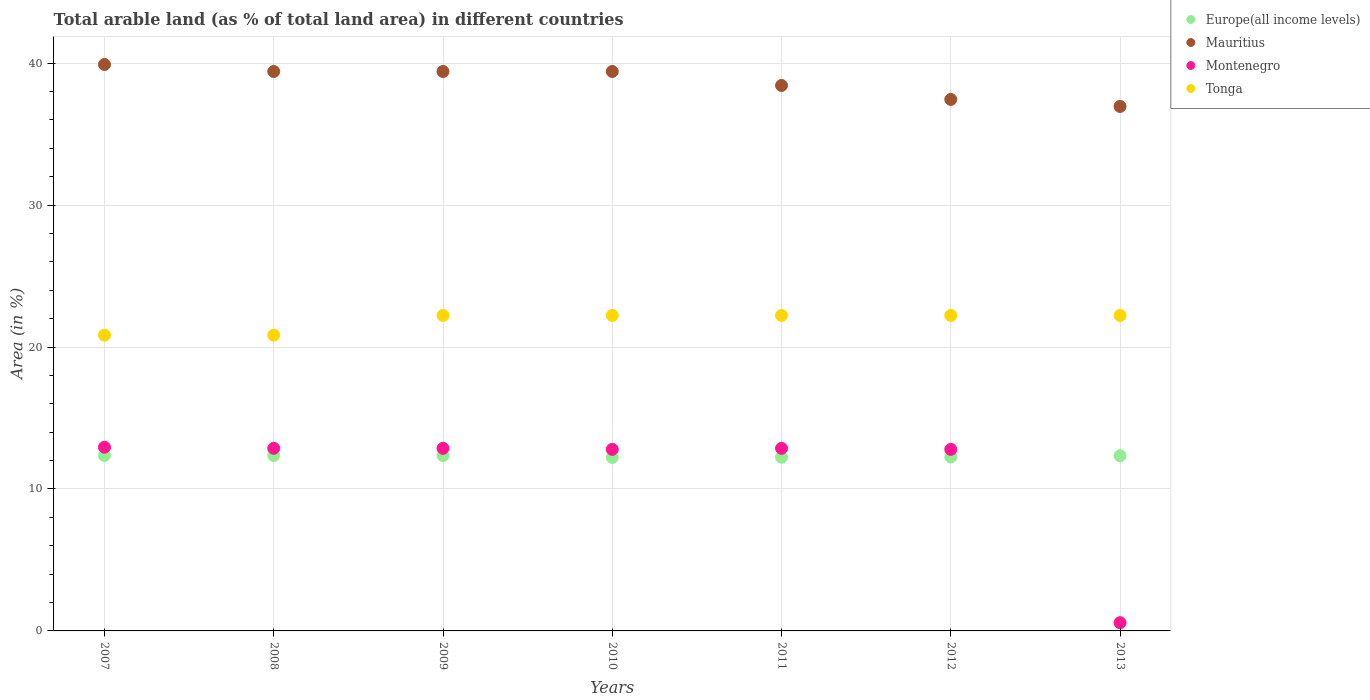How many different coloured dotlines are there?
Keep it short and to the point. 4. What is the percentage of arable land in Europe(all income levels) in 2013?
Your answer should be compact. 12.34. Across all years, what is the maximum percentage of arable land in Tonga?
Provide a succinct answer. 22.22. Across all years, what is the minimum percentage of arable land in Montenegro?
Provide a short and direct response. 0.58. In which year was the percentage of arable land in Montenegro maximum?
Your response must be concise. 2007. What is the total percentage of arable land in Mauritius in the graph?
Your answer should be compact. 270.94. What is the difference between the percentage of arable land in Tonga in 2007 and that in 2013?
Provide a short and direct response. -1.39. What is the difference between the percentage of arable land in Mauritius in 2007 and the percentage of arable land in Montenegro in 2012?
Give a very brief answer. 27.11. What is the average percentage of arable land in Europe(all income levels) per year?
Offer a very short reply. 12.3. In the year 2009, what is the difference between the percentage of arable land in Tonga and percentage of arable land in Europe(all income levels)?
Make the answer very short. 9.87. What is the ratio of the percentage of arable land in Tonga in 2008 to that in 2011?
Ensure brevity in your answer.  0.94. Is the percentage of arable land in Tonga in 2007 less than that in 2010?
Give a very brief answer. Yes. What is the difference between the highest and the second highest percentage of arable land in Montenegro?
Offer a terse response. 0.07. What is the difference between the highest and the lowest percentage of arable land in Mauritius?
Your response must be concise. 2.96. In how many years, is the percentage of arable land in Tonga greater than the average percentage of arable land in Tonga taken over all years?
Give a very brief answer. 5. Is the sum of the percentage of arable land in Montenegro in 2007 and 2008 greater than the maximum percentage of arable land in Europe(all income levels) across all years?
Provide a succinct answer. Yes. Is it the case that in every year, the sum of the percentage of arable land in Mauritius and percentage of arable land in Europe(all income levels)  is greater than the sum of percentage of arable land in Montenegro and percentage of arable land in Tonga?
Your response must be concise. Yes. Is it the case that in every year, the sum of the percentage of arable land in Montenegro and percentage of arable land in Europe(all income levels)  is greater than the percentage of arable land in Mauritius?
Your response must be concise. No. Is the percentage of arable land in Mauritius strictly greater than the percentage of arable land in Montenegro over the years?
Provide a short and direct response. Yes. Is the percentage of arable land in Europe(all income levels) strictly less than the percentage of arable land in Montenegro over the years?
Give a very brief answer. No. What is the difference between two consecutive major ticks on the Y-axis?
Your answer should be very brief. 10. Where does the legend appear in the graph?
Provide a short and direct response. Top right. How many legend labels are there?
Give a very brief answer. 4. How are the legend labels stacked?
Make the answer very short. Vertical. What is the title of the graph?
Make the answer very short. Total arable land (as % of total land area) in different countries. What is the label or title of the X-axis?
Keep it short and to the point. Years. What is the label or title of the Y-axis?
Keep it short and to the point. Area (in %). What is the Area (in %) in Europe(all income levels) in 2007?
Your response must be concise. 12.36. What is the Area (in %) of Mauritius in 2007?
Your answer should be compact. 39.9. What is the Area (in %) of Montenegro in 2007?
Your answer should be very brief. 12.94. What is the Area (in %) of Tonga in 2007?
Your response must be concise. 20.83. What is the Area (in %) of Europe(all income levels) in 2008?
Provide a succinct answer. 12.36. What is the Area (in %) of Mauritius in 2008?
Your answer should be very brief. 39.41. What is the Area (in %) in Montenegro in 2008?
Provide a short and direct response. 12.86. What is the Area (in %) of Tonga in 2008?
Your answer should be very brief. 20.83. What is the Area (in %) in Europe(all income levels) in 2009?
Provide a short and direct response. 12.35. What is the Area (in %) of Mauritius in 2009?
Provide a succinct answer. 39.41. What is the Area (in %) in Montenegro in 2009?
Offer a terse response. 12.86. What is the Area (in %) in Tonga in 2009?
Provide a short and direct response. 22.22. What is the Area (in %) of Europe(all income levels) in 2010?
Provide a succinct answer. 12.22. What is the Area (in %) in Mauritius in 2010?
Ensure brevity in your answer.  39.41. What is the Area (in %) in Montenegro in 2010?
Your response must be concise. 12.79. What is the Area (in %) of Tonga in 2010?
Make the answer very short. 22.22. What is the Area (in %) of Europe(all income levels) in 2011?
Offer a very short reply. 12.24. What is the Area (in %) of Mauritius in 2011?
Ensure brevity in your answer.  38.42. What is the Area (in %) of Montenegro in 2011?
Your response must be concise. 12.86. What is the Area (in %) in Tonga in 2011?
Keep it short and to the point. 22.22. What is the Area (in %) in Europe(all income levels) in 2012?
Your response must be concise. 12.26. What is the Area (in %) in Mauritius in 2012?
Offer a very short reply. 37.44. What is the Area (in %) in Montenegro in 2012?
Make the answer very short. 12.79. What is the Area (in %) in Tonga in 2012?
Provide a short and direct response. 22.22. What is the Area (in %) in Europe(all income levels) in 2013?
Keep it short and to the point. 12.34. What is the Area (in %) in Mauritius in 2013?
Provide a succinct answer. 36.95. What is the Area (in %) in Montenegro in 2013?
Ensure brevity in your answer.  0.58. What is the Area (in %) of Tonga in 2013?
Offer a very short reply. 22.22. Across all years, what is the maximum Area (in %) of Europe(all income levels)?
Offer a terse response. 12.36. Across all years, what is the maximum Area (in %) of Mauritius?
Your response must be concise. 39.9. Across all years, what is the maximum Area (in %) in Montenegro?
Offer a terse response. 12.94. Across all years, what is the maximum Area (in %) of Tonga?
Your answer should be compact. 22.22. Across all years, what is the minimum Area (in %) in Europe(all income levels)?
Make the answer very short. 12.22. Across all years, what is the minimum Area (in %) in Mauritius?
Offer a very short reply. 36.95. Across all years, what is the minimum Area (in %) of Montenegro?
Your response must be concise. 0.58. Across all years, what is the minimum Area (in %) of Tonga?
Ensure brevity in your answer.  20.83. What is the total Area (in %) in Europe(all income levels) in the graph?
Give a very brief answer. 86.12. What is the total Area (in %) of Mauritius in the graph?
Make the answer very short. 270.94. What is the total Area (in %) in Montenegro in the graph?
Make the answer very short. 77.68. What is the total Area (in %) in Tonga in the graph?
Offer a very short reply. 152.78. What is the difference between the Area (in %) in Europe(all income levels) in 2007 and that in 2008?
Provide a short and direct response. 0. What is the difference between the Area (in %) of Mauritius in 2007 and that in 2008?
Your answer should be compact. 0.49. What is the difference between the Area (in %) of Montenegro in 2007 and that in 2008?
Keep it short and to the point. 0.07. What is the difference between the Area (in %) in Europe(all income levels) in 2007 and that in 2009?
Provide a short and direct response. 0.01. What is the difference between the Area (in %) in Mauritius in 2007 and that in 2009?
Ensure brevity in your answer.  0.49. What is the difference between the Area (in %) of Montenegro in 2007 and that in 2009?
Ensure brevity in your answer.  0.07. What is the difference between the Area (in %) of Tonga in 2007 and that in 2009?
Keep it short and to the point. -1.39. What is the difference between the Area (in %) of Europe(all income levels) in 2007 and that in 2010?
Offer a terse response. 0.14. What is the difference between the Area (in %) in Mauritius in 2007 and that in 2010?
Offer a very short reply. 0.49. What is the difference between the Area (in %) in Montenegro in 2007 and that in 2010?
Your answer should be compact. 0.15. What is the difference between the Area (in %) in Tonga in 2007 and that in 2010?
Your answer should be very brief. -1.39. What is the difference between the Area (in %) of Europe(all income levels) in 2007 and that in 2011?
Provide a short and direct response. 0.12. What is the difference between the Area (in %) in Mauritius in 2007 and that in 2011?
Offer a very short reply. 1.48. What is the difference between the Area (in %) in Montenegro in 2007 and that in 2011?
Offer a very short reply. 0.07. What is the difference between the Area (in %) in Tonga in 2007 and that in 2011?
Your answer should be compact. -1.39. What is the difference between the Area (in %) in Europe(all income levels) in 2007 and that in 2012?
Make the answer very short. 0.1. What is the difference between the Area (in %) in Mauritius in 2007 and that in 2012?
Offer a very short reply. 2.46. What is the difference between the Area (in %) in Montenegro in 2007 and that in 2012?
Your response must be concise. 0.15. What is the difference between the Area (in %) in Tonga in 2007 and that in 2012?
Give a very brief answer. -1.39. What is the difference between the Area (in %) in Europe(all income levels) in 2007 and that in 2013?
Your response must be concise. 0.02. What is the difference between the Area (in %) of Mauritius in 2007 and that in 2013?
Give a very brief answer. 2.96. What is the difference between the Area (in %) of Montenegro in 2007 and that in 2013?
Your answer should be compact. 12.36. What is the difference between the Area (in %) in Tonga in 2007 and that in 2013?
Your answer should be very brief. -1.39. What is the difference between the Area (in %) in Europe(all income levels) in 2008 and that in 2009?
Offer a terse response. 0.01. What is the difference between the Area (in %) of Montenegro in 2008 and that in 2009?
Your response must be concise. 0. What is the difference between the Area (in %) in Tonga in 2008 and that in 2009?
Your answer should be compact. -1.39. What is the difference between the Area (in %) of Europe(all income levels) in 2008 and that in 2010?
Make the answer very short. 0.14. What is the difference between the Area (in %) in Montenegro in 2008 and that in 2010?
Your answer should be very brief. 0.07. What is the difference between the Area (in %) in Tonga in 2008 and that in 2010?
Your answer should be very brief. -1.39. What is the difference between the Area (in %) of Europe(all income levels) in 2008 and that in 2011?
Give a very brief answer. 0.12. What is the difference between the Area (in %) in Mauritius in 2008 and that in 2011?
Your answer should be very brief. 0.99. What is the difference between the Area (in %) in Tonga in 2008 and that in 2011?
Your response must be concise. -1.39. What is the difference between the Area (in %) in Europe(all income levels) in 2008 and that in 2012?
Your answer should be very brief. 0.1. What is the difference between the Area (in %) in Mauritius in 2008 and that in 2012?
Your response must be concise. 1.97. What is the difference between the Area (in %) in Montenegro in 2008 and that in 2012?
Provide a short and direct response. 0.07. What is the difference between the Area (in %) in Tonga in 2008 and that in 2012?
Give a very brief answer. -1.39. What is the difference between the Area (in %) in Europe(all income levels) in 2008 and that in 2013?
Ensure brevity in your answer.  0.02. What is the difference between the Area (in %) in Mauritius in 2008 and that in 2013?
Give a very brief answer. 2.46. What is the difference between the Area (in %) in Montenegro in 2008 and that in 2013?
Offer a very short reply. 12.28. What is the difference between the Area (in %) in Tonga in 2008 and that in 2013?
Provide a short and direct response. -1.39. What is the difference between the Area (in %) in Europe(all income levels) in 2009 and that in 2010?
Your answer should be compact. 0.13. What is the difference between the Area (in %) in Montenegro in 2009 and that in 2010?
Your answer should be very brief. 0.07. What is the difference between the Area (in %) in Europe(all income levels) in 2009 and that in 2011?
Make the answer very short. 0.12. What is the difference between the Area (in %) in Mauritius in 2009 and that in 2011?
Make the answer very short. 0.99. What is the difference between the Area (in %) in Europe(all income levels) in 2009 and that in 2012?
Your response must be concise. 0.1. What is the difference between the Area (in %) in Mauritius in 2009 and that in 2012?
Provide a succinct answer. 1.97. What is the difference between the Area (in %) of Montenegro in 2009 and that in 2012?
Give a very brief answer. 0.07. What is the difference between the Area (in %) of Europe(all income levels) in 2009 and that in 2013?
Make the answer very short. 0.01. What is the difference between the Area (in %) of Mauritius in 2009 and that in 2013?
Ensure brevity in your answer.  2.46. What is the difference between the Area (in %) in Montenegro in 2009 and that in 2013?
Provide a succinct answer. 12.28. What is the difference between the Area (in %) in Europe(all income levels) in 2010 and that in 2011?
Your answer should be compact. -0.02. What is the difference between the Area (in %) of Mauritius in 2010 and that in 2011?
Provide a succinct answer. 0.99. What is the difference between the Area (in %) of Montenegro in 2010 and that in 2011?
Ensure brevity in your answer.  -0.07. What is the difference between the Area (in %) of Tonga in 2010 and that in 2011?
Make the answer very short. 0. What is the difference between the Area (in %) of Europe(all income levels) in 2010 and that in 2012?
Your answer should be very brief. -0.04. What is the difference between the Area (in %) in Mauritius in 2010 and that in 2012?
Offer a very short reply. 1.97. What is the difference between the Area (in %) of Montenegro in 2010 and that in 2012?
Your answer should be very brief. 0. What is the difference between the Area (in %) of Tonga in 2010 and that in 2012?
Provide a short and direct response. 0. What is the difference between the Area (in %) of Europe(all income levels) in 2010 and that in 2013?
Make the answer very short. -0.12. What is the difference between the Area (in %) of Mauritius in 2010 and that in 2013?
Keep it short and to the point. 2.46. What is the difference between the Area (in %) of Montenegro in 2010 and that in 2013?
Provide a succinct answer. 12.21. What is the difference between the Area (in %) in Tonga in 2010 and that in 2013?
Provide a succinct answer. 0. What is the difference between the Area (in %) of Europe(all income levels) in 2011 and that in 2012?
Offer a very short reply. -0.02. What is the difference between the Area (in %) of Mauritius in 2011 and that in 2012?
Your answer should be very brief. 0.99. What is the difference between the Area (in %) of Montenegro in 2011 and that in 2012?
Your response must be concise. 0.07. What is the difference between the Area (in %) of Tonga in 2011 and that in 2012?
Give a very brief answer. 0. What is the difference between the Area (in %) of Europe(all income levels) in 2011 and that in 2013?
Your response must be concise. -0.1. What is the difference between the Area (in %) in Mauritius in 2011 and that in 2013?
Your answer should be very brief. 1.48. What is the difference between the Area (in %) of Montenegro in 2011 and that in 2013?
Your answer should be very brief. 12.28. What is the difference between the Area (in %) of Europe(all income levels) in 2012 and that in 2013?
Make the answer very short. -0.08. What is the difference between the Area (in %) in Mauritius in 2012 and that in 2013?
Keep it short and to the point. 0.49. What is the difference between the Area (in %) in Montenegro in 2012 and that in 2013?
Offer a very short reply. 12.21. What is the difference between the Area (in %) in Tonga in 2012 and that in 2013?
Provide a short and direct response. 0. What is the difference between the Area (in %) of Europe(all income levels) in 2007 and the Area (in %) of Mauritius in 2008?
Your response must be concise. -27.05. What is the difference between the Area (in %) in Europe(all income levels) in 2007 and the Area (in %) in Montenegro in 2008?
Your answer should be very brief. -0.5. What is the difference between the Area (in %) of Europe(all income levels) in 2007 and the Area (in %) of Tonga in 2008?
Provide a succinct answer. -8.47. What is the difference between the Area (in %) of Mauritius in 2007 and the Area (in %) of Montenegro in 2008?
Keep it short and to the point. 27.04. What is the difference between the Area (in %) in Mauritius in 2007 and the Area (in %) in Tonga in 2008?
Keep it short and to the point. 19.07. What is the difference between the Area (in %) in Montenegro in 2007 and the Area (in %) in Tonga in 2008?
Your answer should be compact. -7.9. What is the difference between the Area (in %) of Europe(all income levels) in 2007 and the Area (in %) of Mauritius in 2009?
Provide a short and direct response. -27.05. What is the difference between the Area (in %) in Europe(all income levels) in 2007 and the Area (in %) in Montenegro in 2009?
Provide a succinct answer. -0.5. What is the difference between the Area (in %) in Europe(all income levels) in 2007 and the Area (in %) in Tonga in 2009?
Give a very brief answer. -9.86. What is the difference between the Area (in %) in Mauritius in 2007 and the Area (in %) in Montenegro in 2009?
Provide a succinct answer. 27.04. What is the difference between the Area (in %) in Mauritius in 2007 and the Area (in %) in Tonga in 2009?
Keep it short and to the point. 17.68. What is the difference between the Area (in %) of Montenegro in 2007 and the Area (in %) of Tonga in 2009?
Your answer should be compact. -9.29. What is the difference between the Area (in %) of Europe(all income levels) in 2007 and the Area (in %) of Mauritius in 2010?
Provide a succinct answer. -27.05. What is the difference between the Area (in %) in Europe(all income levels) in 2007 and the Area (in %) in Montenegro in 2010?
Your response must be concise. -0.43. What is the difference between the Area (in %) in Europe(all income levels) in 2007 and the Area (in %) in Tonga in 2010?
Offer a terse response. -9.86. What is the difference between the Area (in %) of Mauritius in 2007 and the Area (in %) of Montenegro in 2010?
Your response must be concise. 27.11. What is the difference between the Area (in %) in Mauritius in 2007 and the Area (in %) in Tonga in 2010?
Provide a succinct answer. 17.68. What is the difference between the Area (in %) of Montenegro in 2007 and the Area (in %) of Tonga in 2010?
Give a very brief answer. -9.29. What is the difference between the Area (in %) of Europe(all income levels) in 2007 and the Area (in %) of Mauritius in 2011?
Offer a very short reply. -26.07. What is the difference between the Area (in %) in Europe(all income levels) in 2007 and the Area (in %) in Montenegro in 2011?
Offer a very short reply. -0.5. What is the difference between the Area (in %) of Europe(all income levels) in 2007 and the Area (in %) of Tonga in 2011?
Provide a short and direct response. -9.86. What is the difference between the Area (in %) of Mauritius in 2007 and the Area (in %) of Montenegro in 2011?
Provide a succinct answer. 27.04. What is the difference between the Area (in %) in Mauritius in 2007 and the Area (in %) in Tonga in 2011?
Offer a very short reply. 17.68. What is the difference between the Area (in %) of Montenegro in 2007 and the Area (in %) of Tonga in 2011?
Keep it short and to the point. -9.29. What is the difference between the Area (in %) in Europe(all income levels) in 2007 and the Area (in %) in Mauritius in 2012?
Your answer should be compact. -25.08. What is the difference between the Area (in %) in Europe(all income levels) in 2007 and the Area (in %) in Montenegro in 2012?
Your answer should be compact. -0.43. What is the difference between the Area (in %) of Europe(all income levels) in 2007 and the Area (in %) of Tonga in 2012?
Give a very brief answer. -9.86. What is the difference between the Area (in %) in Mauritius in 2007 and the Area (in %) in Montenegro in 2012?
Keep it short and to the point. 27.11. What is the difference between the Area (in %) of Mauritius in 2007 and the Area (in %) of Tonga in 2012?
Offer a terse response. 17.68. What is the difference between the Area (in %) in Montenegro in 2007 and the Area (in %) in Tonga in 2012?
Offer a very short reply. -9.29. What is the difference between the Area (in %) in Europe(all income levels) in 2007 and the Area (in %) in Mauritius in 2013?
Ensure brevity in your answer.  -24.59. What is the difference between the Area (in %) in Europe(all income levels) in 2007 and the Area (in %) in Montenegro in 2013?
Provide a succinct answer. 11.78. What is the difference between the Area (in %) of Europe(all income levels) in 2007 and the Area (in %) of Tonga in 2013?
Provide a succinct answer. -9.86. What is the difference between the Area (in %) in Mauritius in 2007 and the Area (in %) in Montenegro in 2013?
Provide a succinct answer. 39.32. What is the difference between the Area (in %) in Mauritius in 2007 and the Area (in %) in Tonga in 2013?
Make the answer very short. 17.68. What is the difference between the Area (in %) of Montenegro in 2007 and the Area (in %) of Tonga in 2013?
Offer a very short reply. -9.29. What is the difference between the Area (in %) in Europe(all income levels) in 2008 and the Area (in %) in Mauritius in 2009?
Your answer should be very brief. -27.05. What is the difference between the Area (in %) in Europe(all income levels) in 2008 and the Area (in %) in Montenegro in 2009?
Your response must be concise. -0.5. What is the difference between the Area (in %) in Europe(all income levels) in 2008 and the Area (in %) in Tonga in 2009?
Provide a short and direct response. -9.86. What is the difference between the Area (in %) of Mauritius in 2008 and the Area (in %) of Montenegro in 2009?
Give a very brief answer. 26.55. What is the difference between the Area (in %) of Mauritius in 2008 and the Area (in %) of Tonga in 2009?
Your response must be concise. 17.19. What is the difference between the Area (in %) of Montenegro in 2008 and the Area (in %) of Tonga in 2009?
Provide a succinct answer. -9.36. What is the difference between the Area (in %) in Europe(all income levels) in 2008 and the Area (in %) in Mauritius in 2010?
Your answer should be compact. -27.05. What is the difference between the Area (in %) in Europe(all income levels) in 2008 and the Area (in %) in Montenegro in 2010?
Your response must be concise. -0.43. What is the difference between the Area (in %) in Europe(all income levels) in 2008 and the Area (in %) in Tonga in 2010?
Give a very brief answer. -9.86. What is the difference between the Area (in %) of Mauritius in 2008 and the Area (in %) of Montenegro in 2010?
Provide a succinct answer. 26.62. What is the difference between the Area (in %) of Mauritius in 2008 and the Area (in %) of Tonga in 2010?
Offer a very short reply. 17.19. What is the difference between the Area (in %) in Montenegro in 2008 and the Area (in %) in Tonga in 2010?
Offer a terse response. -9.36. What is the difference between the Area (in %) of Europe(all income levels) in 2008 and the Area (in %) of Mauritius in 2011?
Make the answer very short. -26.07. What is the difference between the Area (in %) of Europe(all income levels) in 2008 and the Area (in %) of Montenegro in 2011?
Provide a succinct answer. -0.5. What is the difference between the Area (in %) of Europe(all income levels) in 2008 and the Area (in %) of Tonga in 2011?
Keep it short and to the point. -9.86. What is the difference between the Area (in %) of Mauritius in 2008 and the Area (in %) of Montenegro in 2011?
Offer a very short reply. 26.55. What is the difference between the Area (in %) of Mauritius in 2008 and the Area (in %) of Tonga in 2011?
Your answer should be very brief. 17.19. What is the difference between the Area (in %) in Montenegro in 2008 and the Area (in %) in Tonga in 2011?
Offer a very short reply. -9.36. What is the difference between the Area (in %) in Europe(all income levels) in 2008 and the Area (in %) in Mauritius in 2012?
Give a very brief answer. -25.08. What is the difference between the Area (in %) of Europe(all income levels) in 2008 and the Area (in %) of Montenegro in 2012?
Provide a succinct answer. -0.43. What is the difference between the Area (in %) in Europe(all income levels) in 2008 and the Area (in %) in Tonga in 2012?
Your response must be concise. -9.86. What is the difference between the Area (in %) of Mauritius in 2008 and the Area (in %) of Montenegro in 2012?
Offer a very short reply. 26.62. What is the difference between the Area (in %) of Mauritius in 2008 and the Area (in %) of Tonga in 2012?
Your response must be concise. 17.19. What is the difference between the Area (in %) in Montenegro in 2008 and the Area (in %) in Tonga in 2012?
Your answer should be very brief. -9.36. What is the difference between the Area (in %) of Europe(all income levels) in 2008 and the Area (in %) of Mauritius in 2013?
Keep it short and to the point. -24.59. What is the difference between the Area (in %) in Europe(all income levels) in 2008 and the Area (in %) in Montenegro in 2013?
Offer a very short reply. 11.78. What is the difference between the Area (in %) of Europe(all income levels) in 2008 and the Area (in %) of Tonga in 2013?
Your response must be concise. -9.86. What is the difference between the Area (in %) of Mauritius in 2008 and the Area (in %) of Montenegro in 2013?
Provide a short and direct response. 38.83. What is the difference between the Area (in %) in Mauritius in 2008 and the Area (in %) in Tonga in 2013?
Your response must be concise. 17.19. What is the difference between the Area (in %) of Montenegro in 2008 and the Area (in %) of Tonga in 2013?
Ensure brevity in your answer.  -9.36. What is the difference between the Area (in %) of Europe(all income levels) in 2009 and the Area (in %) of Mauritius in 2010?
Ensure brevity in your answer.  -27.06. What is the difference between the Area (in %) of Europe(all income levels) in 2009 and the Area (in %) of Montenegro in 2010?
Make the answer very short. -0.44. What is the difference between the Area (in %) of Europe(all income levels) in 2009 and the Area (in %) of Tonga in 2010?
Provide a short and direct response. -9.87. What is the difference between the Area (in %) in Mauritius in 2009 and the Area (in %) in Montenegro in 2010?
Offer a very short reply. 26.62. What is the difference between the Area (in %) in Mauritius in 2009 and the Area (in %) in Tonga in 2010?
Make the answer very short. 17.19. What is the difference between the Area (in %) of Montenegro in 2009 and the Area (in %) of Tonga in 2010?
Provide a short and direct response. -9.36. What is the difference between the Area (in %) in Europe(all income levels) in 2009 and the Area (in %) in Mauritius in 2011?
Your response must be concise. -26.07. What is the difference between the Area (in %) of Europe(all income levels) in 2009 and the Area (in %) of Montenegro in 2011?
Offer a terse response. -0.51. What is the difference between the Area (in %) in Europe(all income levels) in 2009 and the Area (in %) in Tonga in 2011?
Your response must be concise. -9.87. What is the difference between the Area (in %) in Mauritius in 2009 and the Area (in %) in Montenegro in 2011?
Your answer should be very brief. 26.55. What is the difference between the Area (in %) in Mauritius in 2009 and the Area (in %) in Tonga in 2011?
Make the answer very short. 17.19. What is the difference between the Area (in %) of Montenegro in 2009 and the Area (in %) of Tonga in 2011?
Your response must be concise. -9.36. What is the difference between the Area (in %) in Europe(all income levels) in 2009 and the Area (in %) in Mauritius in 2012?
Provide a short and direct response. -25.09. What is the difference between the Area (in %) in Europe(all income levels) in 2009 and the Area (in %) in Montenegro in 2012?
Ensure brevity in your answer.  -0.44. What is the difference between the Area (in %) of Europe(all income levels) in 2009 and the Area (in %) of Tonga in 2012?
Your response must be concise. -9.87. What is the difference between the Area (in %) in Mauritius in 2009 and the Area (in %) in Montenegro in 2012?
Provide a short and direct response. 26.62. What is the difference between the Area (in %) in Mauritius in 2009 and the Area (in %) in Tonga in 2012?
Your response must be concise. 17.19. What is the difference between the Area (in %) of Montenegro in 2009 and the Area (in %) of Tonga in 2012?
Make the answer very short. -9.36. What is the difference between the Area (in %) in Europe(all income levels) in 2009 and the Area (in %) in Mauritius in 2013?
Provide a succinct answer. -24.59. What is the difference between the Area (in %) in Europe(all income levels) in 2009 and the Area (in %) in Montenegro in 2013?
Give a very brief answer. 11.77. What is the difference between the Area (in %) of Europe(all income levels) in 2009 and the Area (in %) of Tonga in 2013?
Offer a very short reply. -9.87. What is the difference between the Area (in %) of Mauritius in 2009 and the Area (in %) of Montenegro in 2013?
Your response must be concise. 38.83. What is the difference between the Area (in %) of Mauritius in 2009 and the Area (in %) of Tonga in 2013?
Your answer should be compact. 17.19. What is the difference between the Area (in %) of Montenegro in 2009 and the Area (in %) of Tonga in 2013?
Your response must be concise. -9.36. What is the difference between the Area (in %) of Europe(all income levels) in 2010 and the Area (in %) of Mauritius in 2011?
Make the answer very short. -26.21. What is the difference between the Area (in %) in Europe(all income levels) in 2010 and the Area (in %) in Montenegro in 2011?
Your answer should be very brief. -0.65. What is the difference between the Area (in %) of Europe(all income levels) in 2010 and the Area (in %) of Tonga in 2011?
Provide a succinct answer. -10. What is the difference between the Area (in %) of Mauritius in 2010 and the Area (in %) of Montenegro in 2011?
Give a very brief answer. 26.55. What is the difference between the Area (in %) of Mauritius in 2010 and the Area (in %) of Tonga in 2011?
Your answer should be very brief. 17.19. What is the difference between the Area (in %) of Montenegro in 2010 and the Area (in %) of Tonga in 2011?
Provide a short and direct response. -9.43. What is the difference between the Area (in %) in Europe(all income levels) in 2010 and the Area (in %) in Mauritius in 2012?
Make the answer very short. -25.22. What is the difference between the Area (in %) in Europe(all income levels) in 2010 and the Area (in %) in Montenegro in 2012?
Provide a short and direct response. -0.57. What is the difference between the Area (in %) of Europe(all income levels) in 2010 and the Area (in %) of Tonga in 2012?
Keep it short and to the point. -10. What is the difference between the Area (in %) of Mauritius in 2010 and the Area (in %) of Montenegro in 2012?
Provide a short and direct response. 26.62. What is the difference between the Area (in %) of Mauritius in 2010 and the Area (in %) of Tonga in 2012?
Provide a short and direct response. 17.19. What is the difference between the Area (in %) of Montenegro in 2010 and the Area (in %) of Tonga in 2012?
Keep it short and to the point. -9.43. What is the difference between the Area (in %) in Europe(all income levels) in 2010 and the Area (in %) in Mauritius in 2013?
Offer a terse response. -24.73. What is the difference between the Area (in %) of Europe(all income levels) in 2010 and the Area (in %) of Montenegro in 2013?
Your answer should be compact. 11.64. What is the difference between the Area (in %) in Europe(all income levels) in 2010 and the Area (in %) in Tonga in 2013?
Offer a terse response. -10. What is the difference between the Area (in %) of Mauritius in 2010 and the Area (in %) of Montenegro in 2013?
Your answer should be very brief. 38.83. What is the difference between the Area (in %) of Mauritius in 2010 and the Area (in %) of Tonga in 2013?
Your answer should be compact. 17.19. What is the difference between the Area (in %) of Montenegro in 2010 and the Area (in %) of Tonga in 2013?
Offer a terse response. -9.43. What is the difference between the Area (in %) in Europe(all income levels) in 2011 and the Area (in %) in Mauritius in 2012?
Offer a terse response. -25.2. What is the difference between the Area (in %) of Europe(all income levels) in 2011 and the Area (in %) of Montenegro in 2012?
Make the answer very short. -0.55. What is the difference between the Area (in %) of Europe(all income levels) in 2011 and the Area (in %) of Tonga in 2012?
Your answer should be very brief. -9.99. What is the difference between the Area (in %) of Mauritius in 2011 and the Area (in %) of Montenegro in 2012?
Offer a very short reply. 25.64. What is the difference between the Area (in %) in Mauritius in 2011 and the Area (in %) in Tonga in 2012?
Provide a succinct answer. 16.2. What is the difference between the Area (in %) of Montenegro in 2011 and the Area (in %) of Tonga in 2012?
Offer a very short reply. -9.36. What is the difference between the Area (in %) of Europe(all income levels) in 2011 and the Area (in %) of Mauritius in 2013?
Offer a very short reply. -24.71. What is the difference between the Area (in %) of Europe(all income levels) in 2011 and the Area (in %) of Montenegro in 2013?
Your response must be concise. 11.66. What is the difference between the Area (in %) in Europe(all income levels) in 2011 and the Area (in %) in Tonga in 2013?
Offer a very short reply. -9.99. What is the difference between the Area (in %) in Mauritius in 2011 and the Area (in %) in Montenegro in 2013?
Your answer should be very brief. 37.84. What is the difference between the Area (in %) in Mauritius in 2011 and the Area (in %) in Tonga in 2013?
Your answer should be very brief. 16.2. What is the difference between the Area (in %) in Montenegro in 2011 and the Area (in %) in Tonga in 2013?
Ensure brevity in your answer.  -9.36. What is the difference between the Area (in %) of Europe(all income levels) in 2012 and the Area (in %) of Mauritius in 2013?
Your response must be concise. -24.69. What is the difference between the Area (in %) in Europe(all income levels) in 2012 and the Area (in %) in Montenegro in 2013?
Provide a short and direct response. 11.68. What is the difference between the Area (in %) in Europe(all income levels) in 2012 and the Area (in %) in Tonga in 2013?
Provide a succinct answer. -9.97. What is the difference between the Area (in %) in Mauritius in 2012 and the Area (in %) in Montenegro in 2013?
Offer a terse response. 36.86. What is the difference between the Area (in %) in Mauritius in 2012 and the Area (in %) in Tonga in 2013?
Offer a terse response. 15.22. What is the difference between the Area (in %) of Montenegro in 2012 and the Area (in %) of Tonga in 2013?
Ensure brevity in your answer.  -9.43. What is the average Area (in %) of Europe(all income levels) per year?
Keep it short and to the point. 12.3. What is the average Area (in %) of Mauritius per year?
Ensure brevity in your answer.  38.71. What is the average Area (in %) of Montenegro per year?
Ensure brevity in your answer.  11.1. What is the average Area (in %) in Tonga per year?
Provide a short and direct response. 21.83. In the year 2007, what is the difference between the Area (in %) in Europe(all income levels) and Area (in %) in Mauritius?
Make the answer very short. -27.54. In the year 2007, what is the difference between the Area (in %) in Europe(all income levels) and Area (in %) in Montenegro?
Make the answer very short. -0.58. In the year 2007, what is the difference between the Area (in %) in Europe(all income levels) and Area (in %) in Tonga?
Give a very brief answer. -8.47. In the year 2007, what is the difference between the Area (in %) in Mauritius and Area (in %) in Montenegro?
Provide a succinct answer. 26.96. In the year 2007, what is the difference between the Area (in %) of Mauritius and Area (in %) of Tonga?
Give a very brief answer. 19.07. In the year 2007, what is the difference between the Area (in %) of Montenegro and Area (in %) of Tonga?
Your response must be concise. -7.9. In the year 2008, what is the difference between the Area (in %) in Europe(all income levels) and Area (in %) in Mauritius?
Make the answer very short. -27.05. In the year 2008, what is the difference between the Area (in %) of Europe(all income levels) and Area (in %) of Montenegro?
Ensure brevity in your answer.  -0.5. In the year 2008, what is the difference between the Area (in %) of Europe(all income levels) and Area (in %) of Tonga?
Your response must be concise. -8.48. In the year 2008, what is the difference between the Area (in %) of Mauritius and Area (in %) of Montenegro?
Offer a very short reply. 26.55. In the year 2008, what is the difference between the Area (in %) in Mauritius and Area (in %) in Tonga?
Make the answer very short. 18.58. In the year 2008, what is the difference between the Area (in %) in Montenegro and Area (in %) in Tonga?
Your answer should be very brief. -7.97. In the year 2009, what is the difference between the Area (in %) of Europe(all income levels) and Area (in %) of Mauritius?
Keep it short and to the point. -27.06. In the year 2009, what is the difference between the Area (in %) in Europe(all income levels) and Area (in %) in Montenegro?
Your response must be concise. -0.51. In the year 2009, what is the difference between the Area (in %) of Europe(all income levels) and Area (in %) of Tonga?
Ensure brevity in your answer.  -9.87. In the year 2009, what is the difference between the Area (in %) of Mauritius and Area (in %) of Montenegro?
Provide a succinct answer. 26.55. In the year 2009, what is the difference between the Area (in %) in Mauritius and Area (in %) in Tonga?
Provide a short and direct response. 17.19. In the year 2009, what is the difference between the Area (in %) in Montenegro and Area (in %) in Tonga?
Your response must be concise. -9.36. In the year 2010, what is the difference between the Area (in %) of Europe(all income levels) and Area (in %) of Mauritius?
Your answer should be compact. -27.19. In the year 2010, what is the difference between the Area (in %) in Europe(all income levels) and Area (in %) in Montenegro?
Keep it short and to the point. -0.57. In the year 2010, what is the difference between the Area (in %) of Europe(all income levels) and Area (in %) of Tonga?
Make the answer very short. -10. In the year 2010, what is the difference between the Area (in %) in Mauritius and Area (in %) in Montenegro?
Your answer should be compact. 26.62. In the year 2010, what is the difference between the Area (in %) in Mauritius and Area (in %) in Tonga?
Ensure brevity in your answer.  17.19. In the year 2010, what is the difference between the Area (in %) in Montenegro and Area (in %) in Tonga?
Give a very brief answer. -9.43. In the year 2011, what is the difference between the Area (in %) of Europe(all income levels) and Area (in %) of Mauritius?
Provide a succinct answer. -26.19. In the year 2011, what is the difference between the Area (in %) of Europe(all income levels) and Area (in %) of Montenegro?
Ensure brevity in your answer.  -0.63. In the year 2011, what is the difference between the Area (in %) in Europe(all income levels) and Area (in %) in Tonga?
Keep it short and to the point. -9.99. In the year 2011, what is the difference between the Area (in %) in Mauritius and Area (in %) in Montenegro?
Make the answer very short. 25.56. In the year 2011, what is the difference between the Area (in %) in Mauritius and Area (in %) in Tonga?
Provide a short and direct response. 16.2. In the year 2011, what is the difference between the Area (in %) of Montenegro and Area (in %) of Tonga?
Offer a terse response. -9.36. In the year 2012, what is the difference between the Area (in %) of Europe(all income levels) and Area (in %) of Mauritius?
Ensure brevity in your answer.  -25.18. In the year 2012, what is the difference between the Area (in %) in Europe(all income levels) and Area (in %) in Montenegro?
Offer a terse response. -0.53. In the year 2012, what is the difference between the Area (in %) in Europe(all income levels) and Area (in %) in Tonga?
Offer a very short reply. -9.97. In the year 2012, what is the difference between the Area (in %) of Mauritius and Area (in %) of Montenegro?
Make the answer very short. 24.65. In the year 2012, what is the difference between the Area (in %) of Mauritius and Area (in %) of Tonga?
Provide a succinct answer. 15.22. In the year 2012, what is the difference between the Area (in %) of Montenegro and Area (in %) of Tonga?
Make the answer very short. -9.43. In the year 2013, what is the difference between the Area (in %) of Europe(all income levels) and Area (in %) of Mauritius?
Provide a short and direct response. -24.61. In the year 2013, what is the difference between the Area (in %) in Europe(all income levels) and Area (in %) in Montenegro?
Your answer should be compact. 11.76. In the year 2013, what is the difference between the Area (in %) of Europe(all income levels) and Area (in %) of Tonga?
Your answer should be very brief. -9.88. In the year 2013, what is the difference between the Area (in %) of Mauritius and Area (in %) of Montenegro?
Keep it short and to the point. 36.37. In the year 2013, what is the difference between the Area (in %) in Mauritius and Area (in %) in Tonga?
Your answer should be compact. 14.72. In the year 2013, what is the difference between the Area (in %) of Montenegro and Area (in %) of Tonga?
Provide a short and direct response. -21.64. What is the ratio of the Area (in %) in Europe(all income levels) in 2007 to that in 2008?
Provide a succinct answer. 1. What is the ratio of the Area (in %) of Mauritius in 2007 to that in 2008?
Offer a terse response. 1.01. What is the ratio of the Area (in %) of Montenegro in 2007 to that in 2008?
Ensure brevity in your answer.  1.01. What is the ratio of the Area (in %) of Tonga in 2007 to that in 2008?
Offer a terse response. 1. What is the ratio of the Area (in %) in Europe(all income levels) in 2007 to that in 2009?
Give a very brief answer. 1. What is the ratio of the Area (in %) of Mauritius in 2007 to that in 2009?
Ensure brevity in your answer.  1.01. What is the ratio of the Area (in %) in Europe(all income levels) in 2007 to that in 2010?
Make the answer very short. 1.01. What is the ratio of the Area (in %) of Mauritius in 2007 to that in 2010?
Keep it short and to the point. 1.01. What is the ratio of the Area (in %) of Montenegro in 2007 to that in 2010?
Provide a succinct answer. 1.01. What is the ratio of the Area (in %) in Montenegro in 2007 to that in 2011?
Ensure brevity in your answer.  1.01. What is the ratio of the Area (in %) in Tonga in 2007 to that in 2011?
Provide a short and direct response. 0.94. What is the ratio of the Area (in %) of Europe(all income levels) in 2007 to that in 2012?
Your answer should be very brief. 1.01. What is the ratio of the Area (in %) of Mauritius in 2007 to that in 2012?
Offer a terse response. 1.07. What is the ratio of the Area (in %) in Montenegro in 2007 to that in 2012?
Offer a terse response. 1.01. What is the ratio of the Area (in %) of Tonga in 2007 to that in 2012?
Your answer should be very brief. 0.94. What is the ratio of the Area (in %) of Europe(all income levels) in 2007 to that in 2013?
Provide a short and direct response. 1. What is the ratio of the Area (in %) of Mauritius in 2007 to that in 2013?
Provide a succinct answer. 1.08. What is the ratio of the Area (in %) of Montenegro in 2007 to that in 2013?
Provide a short and direct response. 22.31. What is the ratio of the Area (in %) of Tonga in 2007 to that in 2013?
Provide a short and direct response. 0.94. What is the ratio of the Area (in %) of Mauritius in 2008 to that in 2009?
Offer a very short reply. 1. What is the ratio of the Area (in %) in Tonga in 2008 to that in 2009?
Ensure brevity in your answer.  0.94. What is the ratio of the Area (in %) of Europe(all income levels) in 2008 to that in 2010?
Ensure brevity in your answer.  1.01. What is the ratio of the Area (in %) of Mauritius in 2008 to that in 2010?
Your answer should be very brief. 1. What is the ratio of the Area (in %) in Montenegro in 2008 to that in 2010?
Provide a succinct answer. 1.01. What is the ratio of the Area (in %) in Tonga in 2008 to that in 2010?
Your response must be concise. 0.94. What is the ratio of the Area (in %) in Europe(all income levels) in 2008 to that in 2011?
Offer a very short reply. 1.01. What is the ratio of the Area (in %) of Mauritius in 2008 to that in 2011?
Offer a very short reply. 1.03. What is the ratio of the Area (in %) in Montenegro in 2008 to that in 2011?
Keep it short and to the point. 1. What is the ratio of the Area (in %) in Tonga in 2008 to that in 2011?
Provide a short and direct response. 0.94. What is the ratio of the Area (in %) of Europe(all income levels) in 2008 to that in 2012?
Give a very brief answer. 1.01. What is the ratio of the Area (in %) of Mauritius in 2008 to that in 2012?
Ensure brevity in your answer.  1.05. What is the ratio of the Area (in %) of Europe(all income levels) in 2008 to that in 2013?
Your answer should be compact. 1. What is the ratio of the Area (in %) in Mauritius in 2008 to that in 2013?
Give a very brief answer. 1.07. What is the ratio of the Area (in %) in Montenegro in 2008 to that in 2013?
Offer a terse response. 22.18. What is the ratio of the Area (in %) of Tonga in 2008 to that in 2013?
Your answer should be very brief. 0.94. What is the ratio of the Area (in %) in Europe(all income levels) in 2009 to that in 2010?
Keep it short and to the point. 1.01. What is the ratio of the Area (in %) of Tonga in 2009 to that in 2010?
Keep it short and to the point. 1. What is the ratio of the Area (in %) of Europe(all income levels) in 2009 to that in 2011?
Your answer should be very brief. 1.01. What is the ratio of the Area (in %) in Mauritius in 2009 to that in 2011?
Make the answer very short. 1.03. What is the ratio of the Area (in %) in Montenegro in 2009 to that in 2011?
Your response must be concise. 1. What is the ratio of the Area (in %) of Tonga in 2009 to that in 2011?
Ensure brevity in your answer.  1. What is the ratio of the Area (in %) in Europe(all income levels) in 2009 to that in 2012?
Ensure brevity in your answer.  1.01. What is the ratio of the Area (in %) of Mauritius in 2009 to that in 2012?
Give a very brief answer. 1.05. What is the ratio of the Area (in %) in Montenegro in 2009 to that in 2012?
Your answer should be very brief. 1.01. What is the ratio of the Area (in %) of Tonga in 2009 to that in 2012?
Provide a succinct answer. 1. What is the ratio of the Area (in %) in Europe(all income levels) in 2009 to that in 2013?
Give a very brief answer. 1. What is the ratio of the Area (in %) in Mauritius in 2009 to that in 2013?
Keep it short and to the point. 1.07. What is the ratio of the Area (in %) in Montenegro in 2009 to that in 2013?
Provide a succinct answer. 22.18. What is the ratio of the Area (in %) in Mauritius in 2010 to that in 2011?
Offer a very short reply. 1.03. What is the ratio of the Area (in %) in Tonga in 2010 to that in 2011?
Give a very brief answer. 1. What is the ratio of the Area (in %) of Europe(all income levels) in 2010 to that in 2012?
Offer a terse response. 1. What is the ratio of the Area (in %) in Mauritius in 2010 to that in 2012?
Provide a succinct answer. 1.05. What is the ratio of the Area (in %) in Tonga in 2010 to that in 2012?
Make the answer very short. 1. What is the ratio of the Area (in %) in Mauritius in 2010 to that in 2013?
Provide a short and direct response. 1.07. What is the ratio of the Area (in %) of Montenegro in 2010 to that in 2013?
Give a very brief answer. 22.05. What is the ratio of the Area (in %) of Mauritius in 2011 to that in 2012?
Keep it short and to the point. 1.03. What is the ratio of the Area (in %) in Europe(all income levels) in 2011 to that in 2013?
Offer a terse response. 0.99. What is the ratio of the Area (in %) in Mauritius in 2011 to that in 2013?
Ensure brevity in your answer.  1.04. What is the ratio of the Area (in %) in Montenegro in 2011 to that in 2013?
Your answer should be very brief. 22.18. What is the ratio of the Area (in %) in Tonga in 2011 to that in 2013?
Provide a short and direct response. 1. What is the ratio of the Area (in %) in Mauritius in 2012 to that in 2013?
Provide a succinct answer. 1.01. What is the ratio of the Area (in %) in Montenegro in 2012 to that in 2013?
Provide a short and direct response. 22.05. What is the ratio of the Area (in %) of Tonga in 2012 to that in 2013?
Ensure brevity in your answer.  1. What is the difference between the highest and the second highest Area (in %) of Europe(all income levels)?
Ensure brevity in your answer.  0. What is the difference between the highest and the second highest Area (in %) of Mauritius?
Your answer should be compact. 0.49. What is the difference between the highest and the second highest Area (in %) of Montenegro?
Provide a short and direct response. 0.07. What is the difference between the highest and the second highest Area (in %) of Tonga?
Your answer should be compact. 0. What is the difference between the highest and the lowest Area (in %) of Europe(all income levels)?
Provide a succinct answer. 0.14. What is the difference between the highest and the lowest Area (in %) in Mauritius?
Give a very brief answer. 2.96. What is the difference between the highest and the lowest Area (in %) in Montenegro?
Ensure brevity in your answer.  12.36. What is the difference between the highest and the lowest Area (in %) of Tonga?
Your answer should be very brief. 1.39. 